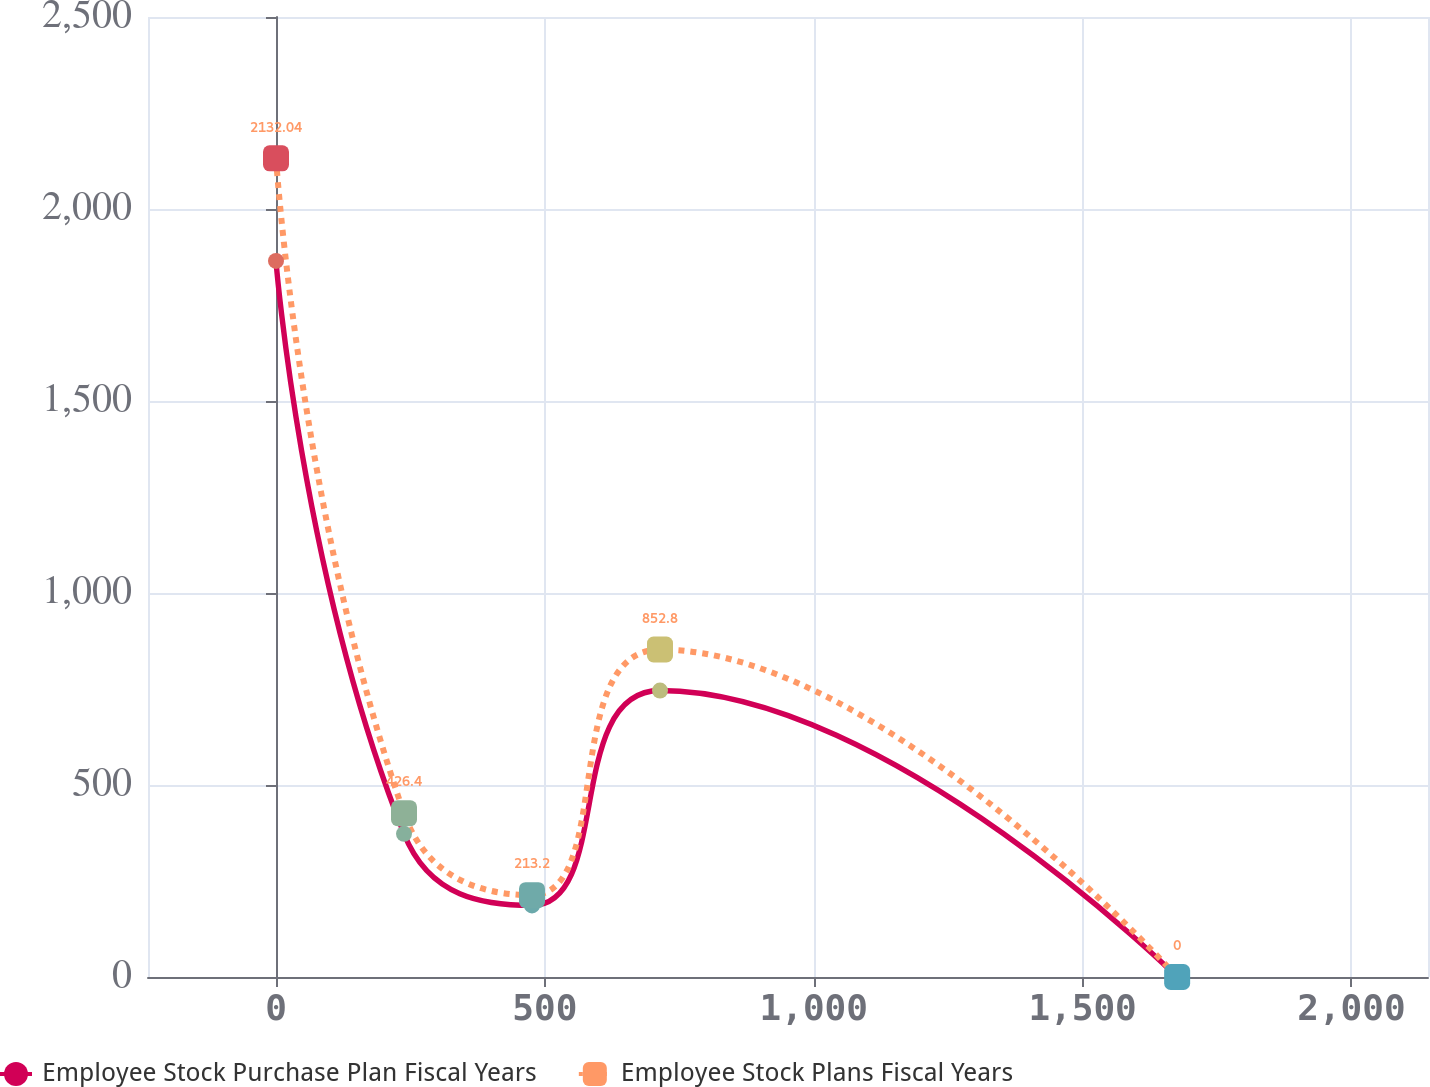<chart> <loc_0><loc_0><loc_500><loc_500><line_chart><ecel><fcel>Employee Stock Purchase Plan Fiscal Years<fcel>Employee Stock Plans Fiscal Years<nl><fcel>0<fcel>1864.75<fcel>2132.04<nl><fcel>238.04<fcel>372.96<fcel>426.4<nl><fcel>476.08<fcel>186.48<fcel>213.2<nl><fcel>714.12<fcel>745.9<fcel>852.8<nl><fcel>1675.85<fcel>0<fcel>0<nl><fcel>2380.4<fcel>559.43<fcel>639.6<nl></chart> 